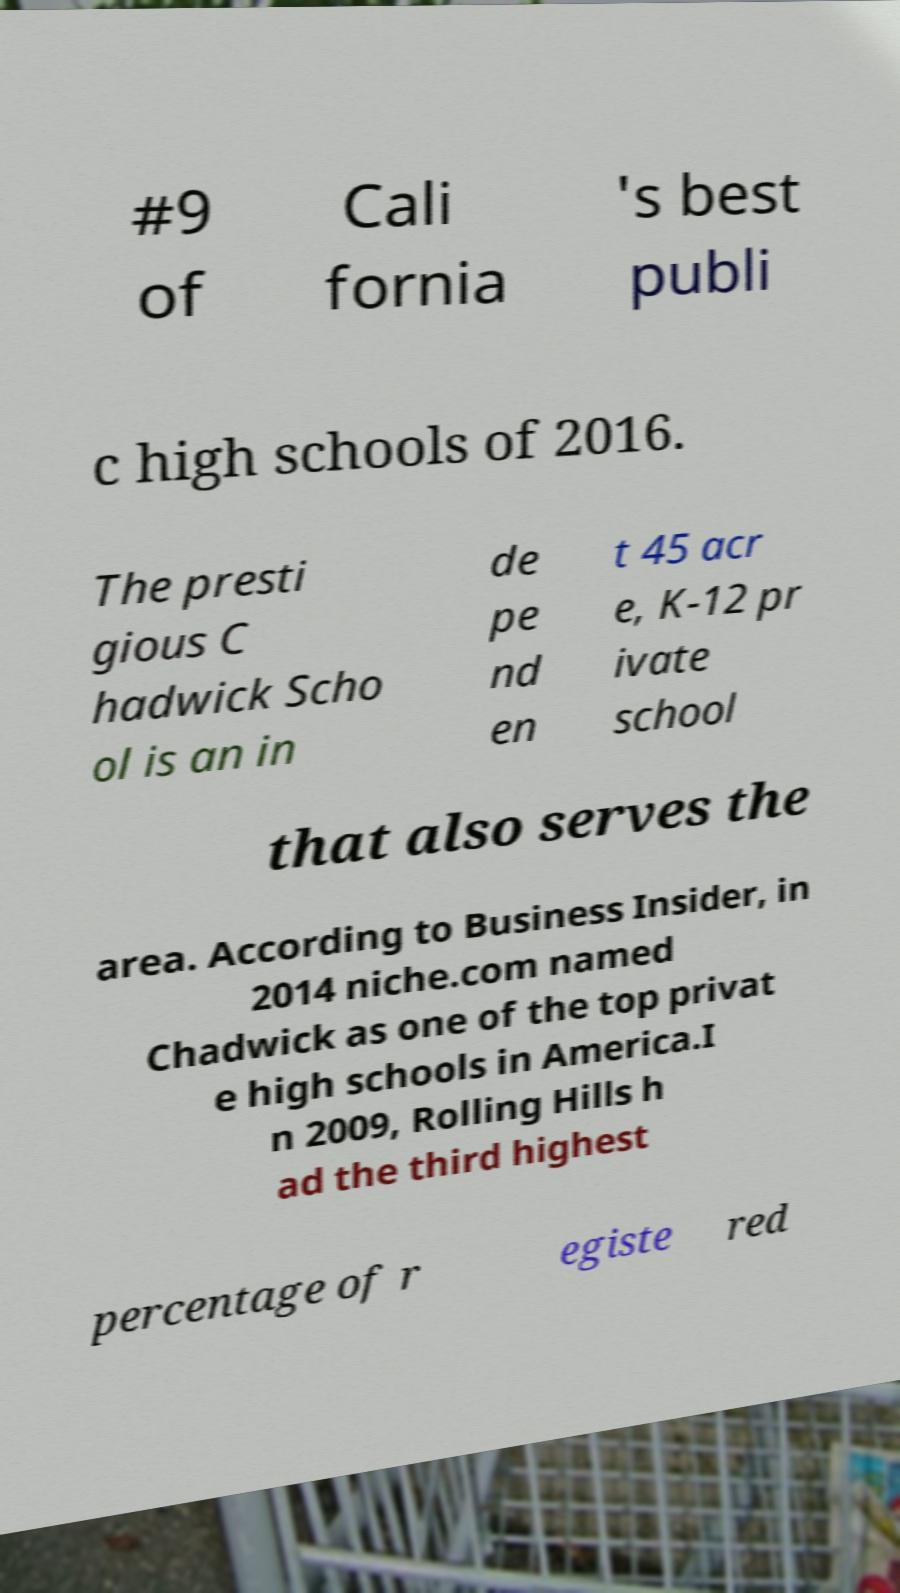There's text embedded in this image that I need extracted. Can you transcribe it verbatim? #9 of Cali fornia 's best publi c high schools of 2016. The presti gious C hadwick Scho ol is an in de pe nd en t 45 acr e, K-12 pr ivate school that also serves the area. According to Business Insider, in 2014 niche.com named Chadwick as one of the top privat e high schools in America.I n 2009, Rolling Hills h ad the third highest percentage of r egiste red 